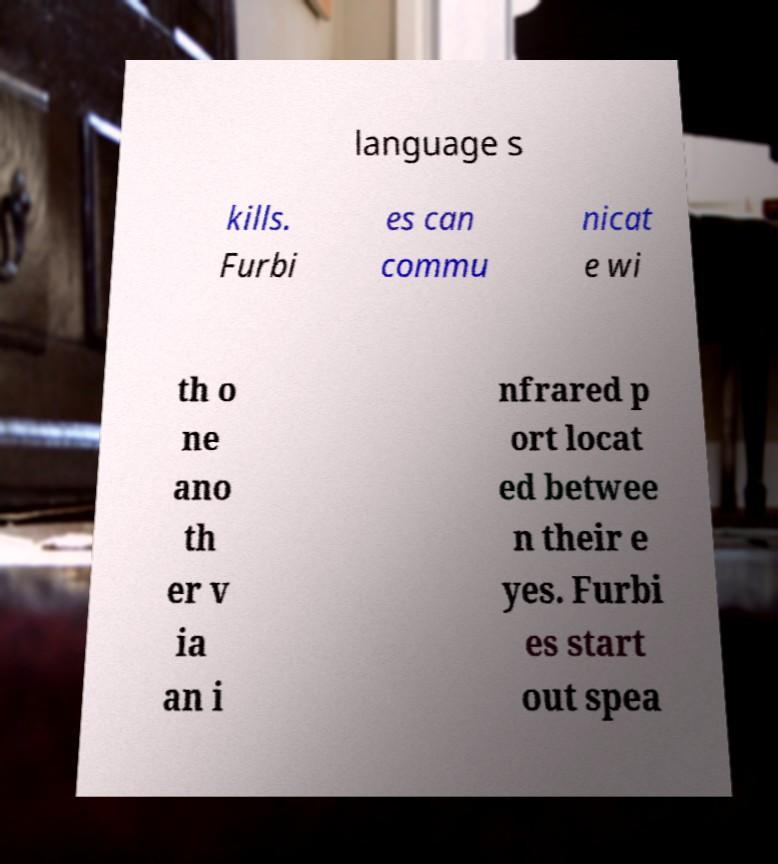Can you read and provide the text displayed in the image?This photo seems to have some interesting text. Can you extract and type it out for me? language s kills. Furbi es can commu nicat e wi th o ne ano th er v ia an i nfrared p ort locat ed betwee n their e yes. Furbi es start out spea 